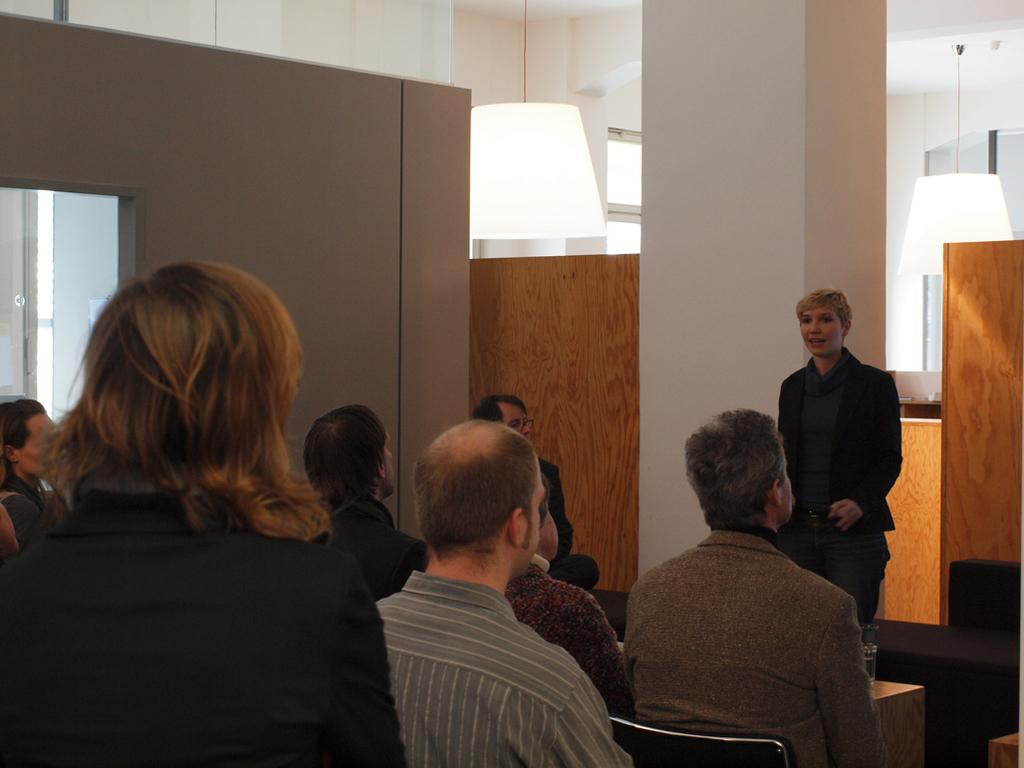What are the people in the image doing? The people in the image are sitting and standing. Can you describe the actions of the people in the image? One person is standing, and another person is talking. How many people are in the image? There are at least two people in the image. What type of sweater is the person wearing in the image? There is no information about a sweater in the image, as the facts provided do not mention any clothing items. 